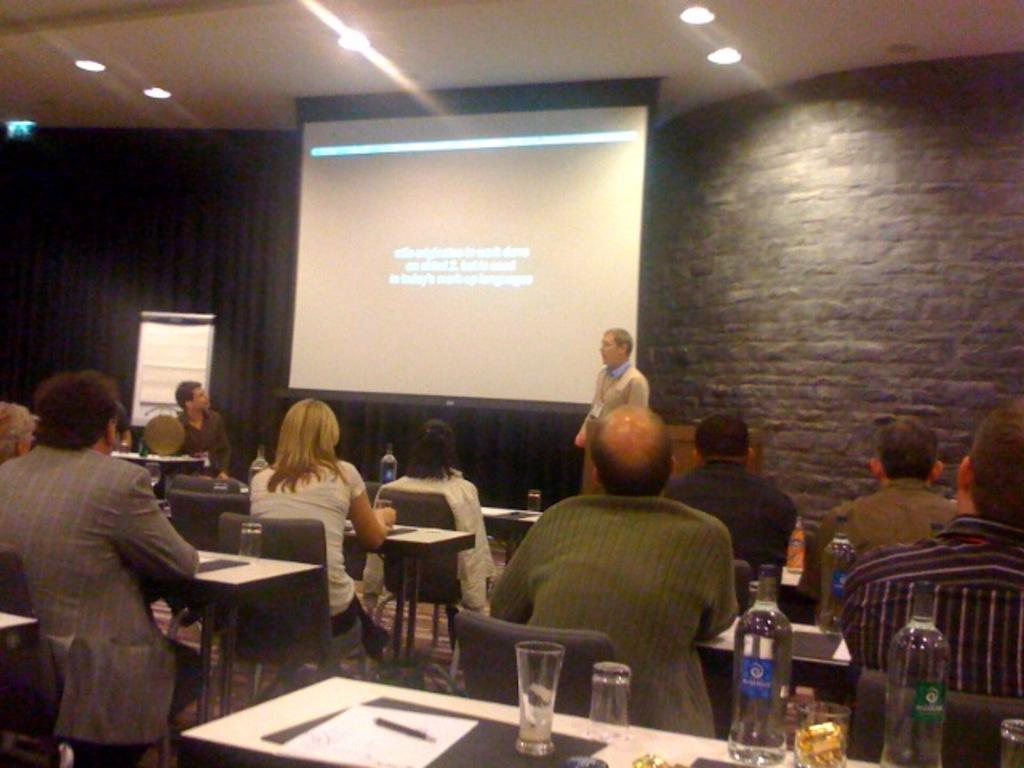How many people are in the image? There is a group of people in the image. What is the man in the image doing? The man is presenting in the image. What is the man using as a visual aid during his presentation? The man is using a screen as a visual aid. What time is displayed on the clock in the image? There is no clock present in the image. What season is depicted in the image? The image does not depict a specific season, as there are no seasonal cues present. 